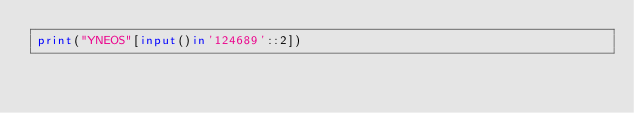Convert code to text. <code><loc_0><loc_0><loc_500><loc_500><_Python_>print("YNEOS"[input()in'124689'::2])</code> 